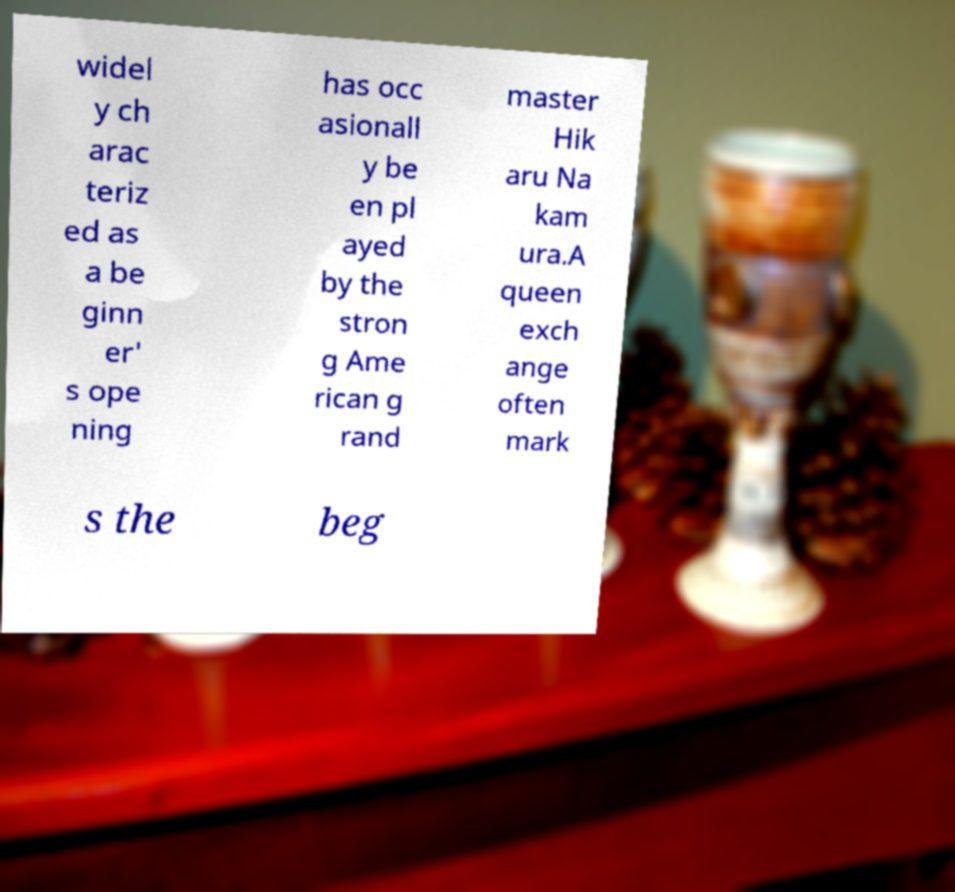Could you assist in decoding the text presented in this image and type it out clearly? widel y ch arac teriz ed as a be ginn er' s ope ning has occ asionall y be en pl ayed by the stron g Ame rican g rand master Hik aru Na kam ura.A queen exch ange often mark s the beg 